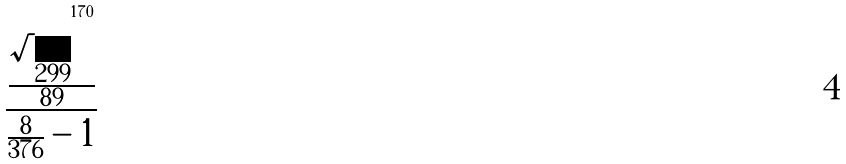Convert formula to latex. <formula><loc_0><loc_0><loc_500><loc_500>\frac { \frac { \sqrt { 2 9 9 } ^ { 1 7 0 } } { 8 9 } } { \frac { 8 } { 3 7 6 } - 1 }</formula> 